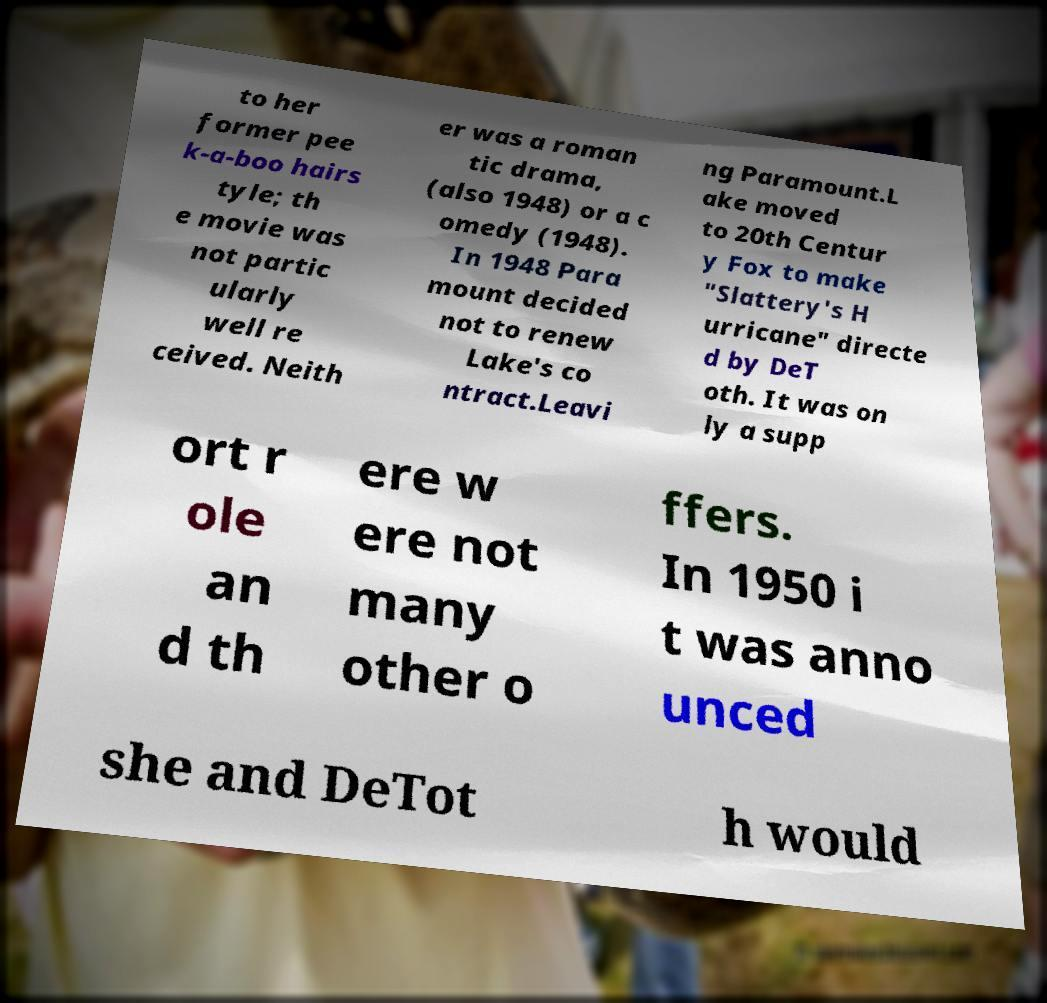Can you read and provide the text displayed in the image?This photo seems to have some interesting text. Can you extract and type it out for me? to her former pee k-a-boo hairs tyle; th e movie was not partic ularly well re ceived. Neith er was a roman tic drama, (also 1948) or a c omedy (1948). In 1948 Para mount decided not to renew Lake's co ntract.Leavi ng Paramount.L ake moved to 20th Centur y Fox to make "Slattery's H urricane" directe d by DeT oth. It was on ly a supp ort r ole an d th ere w ere not many other o ffers. In 1950 i t was anno unced she and DeTot h would 